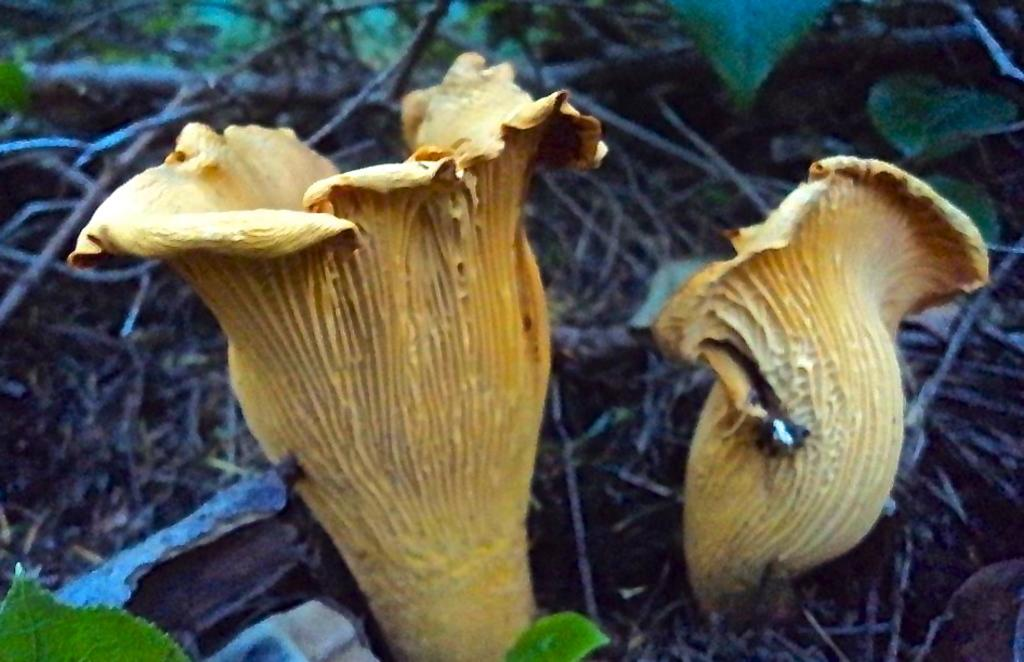What type of fungi can be seen in the image? There are mushrooms in the image. What type of plant material is present in the image? There are leaves in the image. What type of woody plant parts can be seen in the image? There are sticks in the image. What type of advice can be heard from the bell in the image? There is no bell present in the image, so no advice can be heard. Where might someone go on vacation based on the image? The image does not provide any information about a vacation destination. 